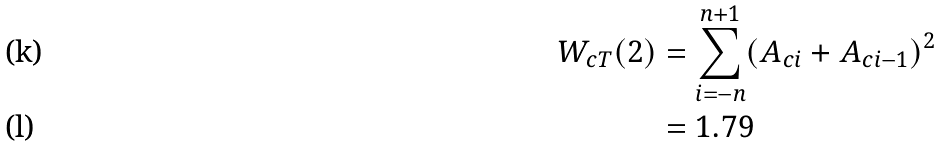<formula> <loc_0><loc_0><loc_500><loc_500>W _ { c T } ( 2 ) & = \sum _ { i = - n } ^ { n + 1 } ( A _ { c i } + A _ { c i - 1 } ) ^ { 2 } \\ & = 1 . 7 9</formula> 